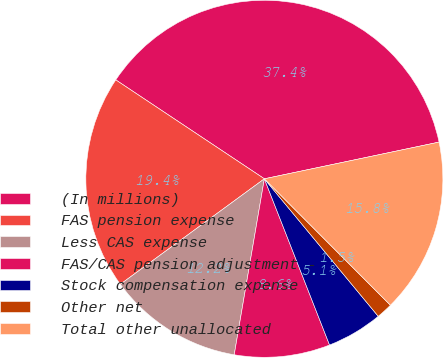Convert chart. <chart><loc_0><loc_0><loc_500><loc_500><pie_chart><fcel>(In millions)<fcel>FAS pension expense<fcel>Less CAS expense<fcel>FAS/CAS pension adjustment -<fcel>Stock compensation expense<fcel>Other net<fcel>Total other unallocated<nl><fcel>37.36%<fcel>19.41%<fcel>12.24%<fcel>8.65%<fcel>5.06%<fcel>1.47%<fcel>15.82%<nl></chart> 